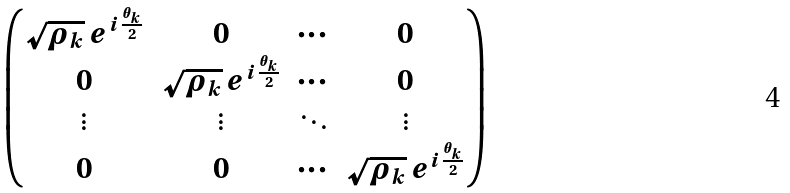Convert formula to latex. <formula><loc_0><loc_0><loc_500><loc_500>\begin{pmatrix} \sqrt { \rho _ { k } } \, e ^ { i \frac { \theta _ { k } } { 2 } } & 0 & \cdots & 0 \\ 0 & \sqrt { \rho _ { k } } \, e ^ { i \frac { \theta _ { k } } { 2 } } & \cdots & 0 \\ \vdots & \vdots & \ddots & \vdots \\ 0 & 0 & \cdots & \sqrt { \rho _ { k } } \, e ^ { i \frac { \theta _ { k } } { 2 } } \end{pmatrix}</formula> 